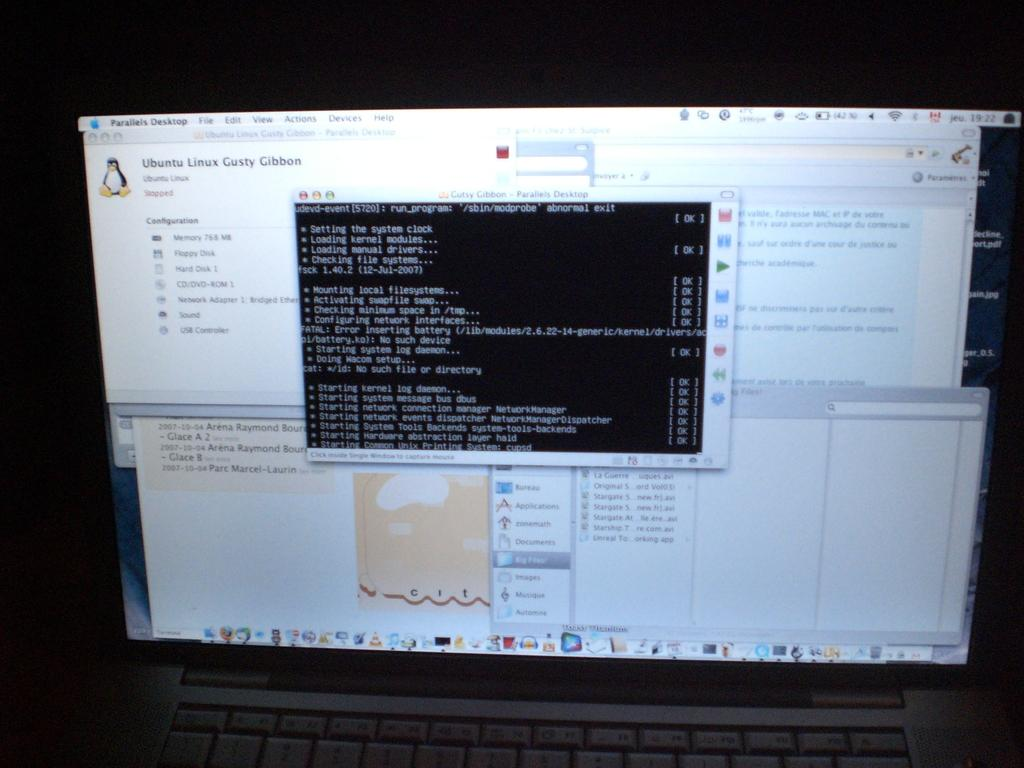What is the main object in the image? There is a laptop screen in the image. What feature of the laptop is visible in the image? The laptop has keys. What can be observed about the overall lighting in the image? The background of the image is dark. What word is written on the substance in the image? There is no substance or word present in the image; it only features a laptop screen and keys. 